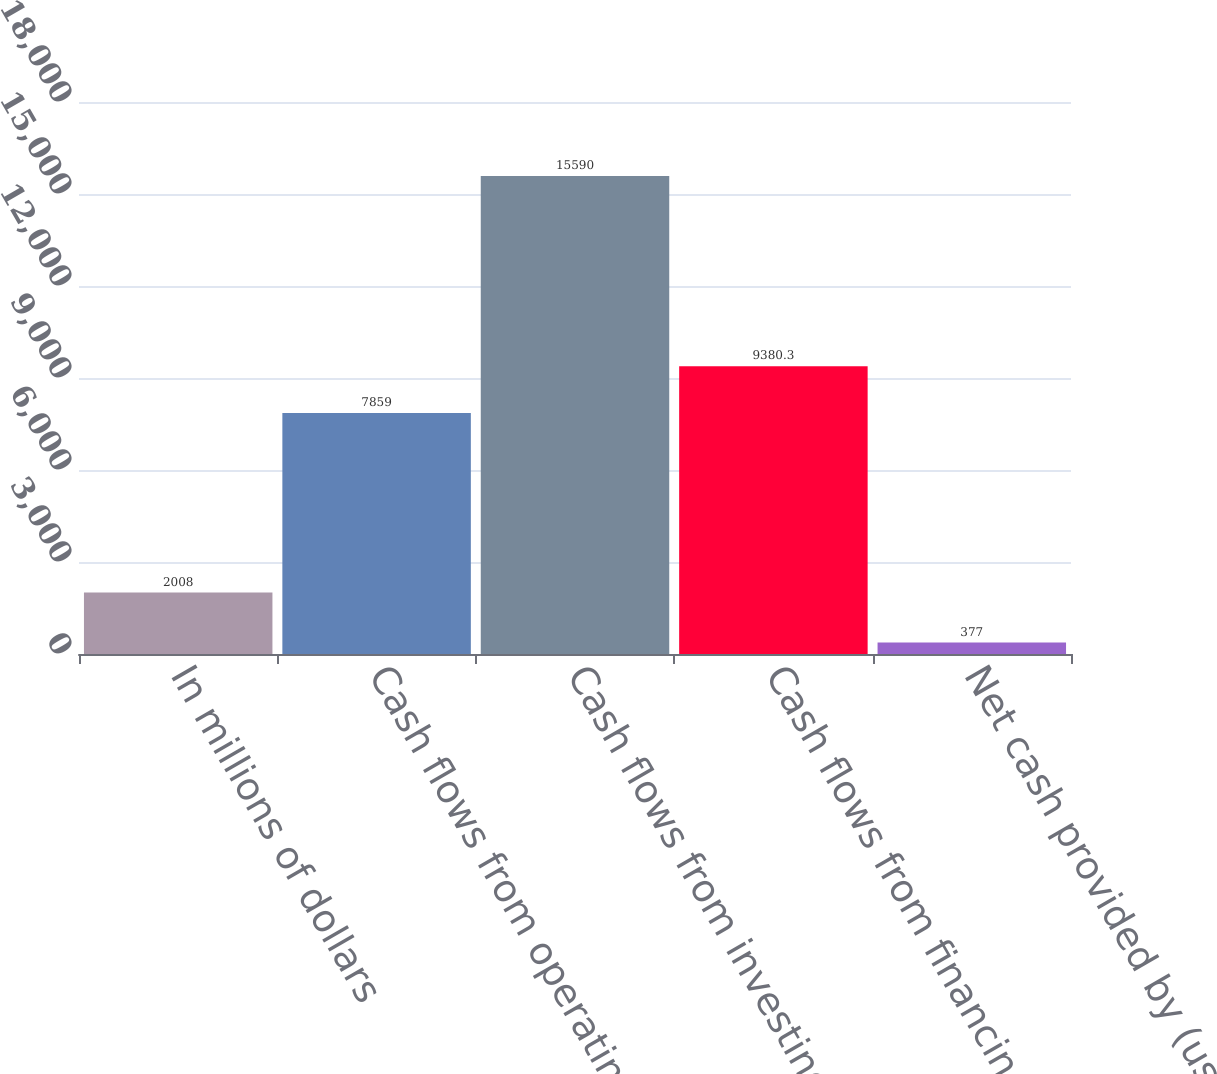<chart> <loc_0><loc_0><loc_500><loc_500><bar_chart><fcel>In millions of dollars<fcel>Cash flows from operating<fcel>Cash flows from investing<fcel>Cash flows from financing<fcel>Net cash provided by (used in)<nl><fcel>2008<fcel>7859<fcel>15590<fcel>9380.3<fcel>377<nl></chart> 